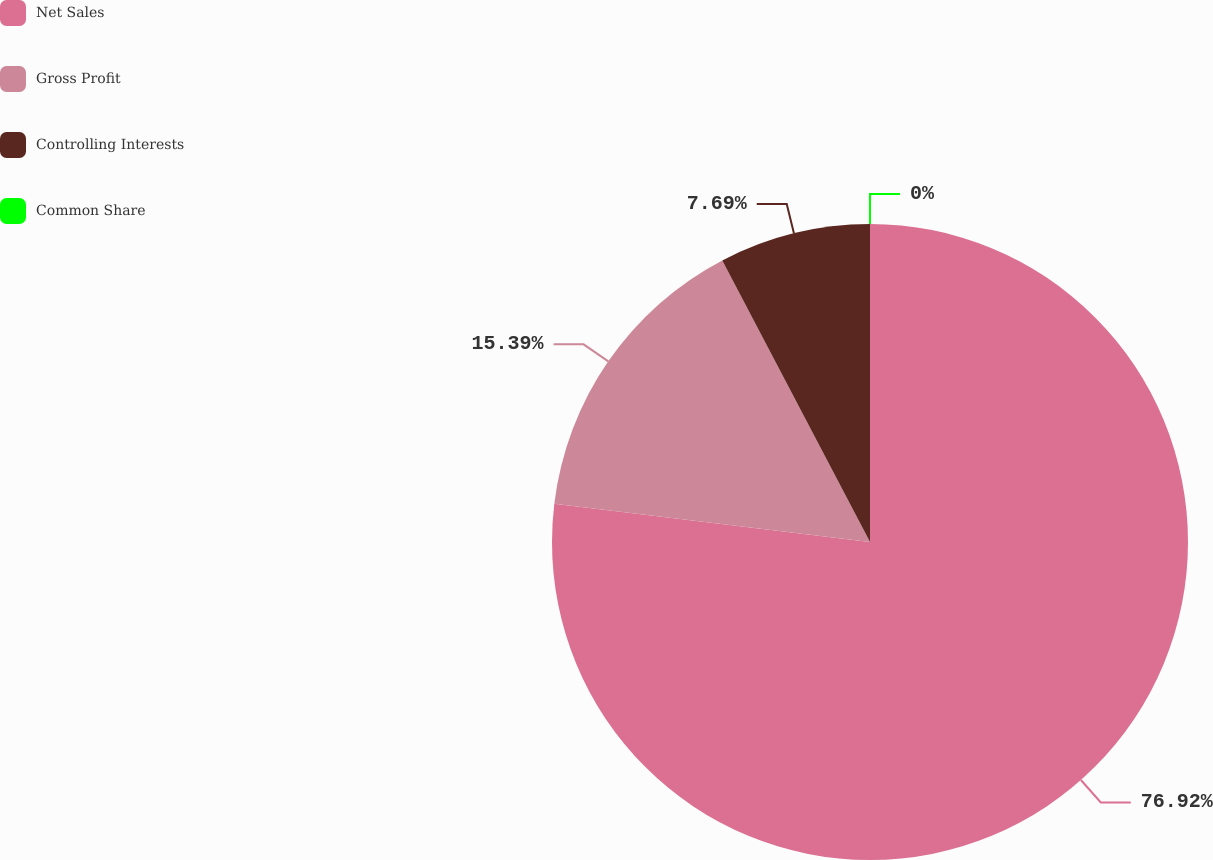Convert chart to OTSL. <chart><loc_0><loc_0><loc_500><loc_500><pie_chart><fcel>Net Sales<fcel>Gross Profit<fcel>Controlling Interests<fcel>Common Share<nl><fcel>76.92%<fcel>15.39%<fcel>7.69%<fcel>0.0%<nl></chart> 